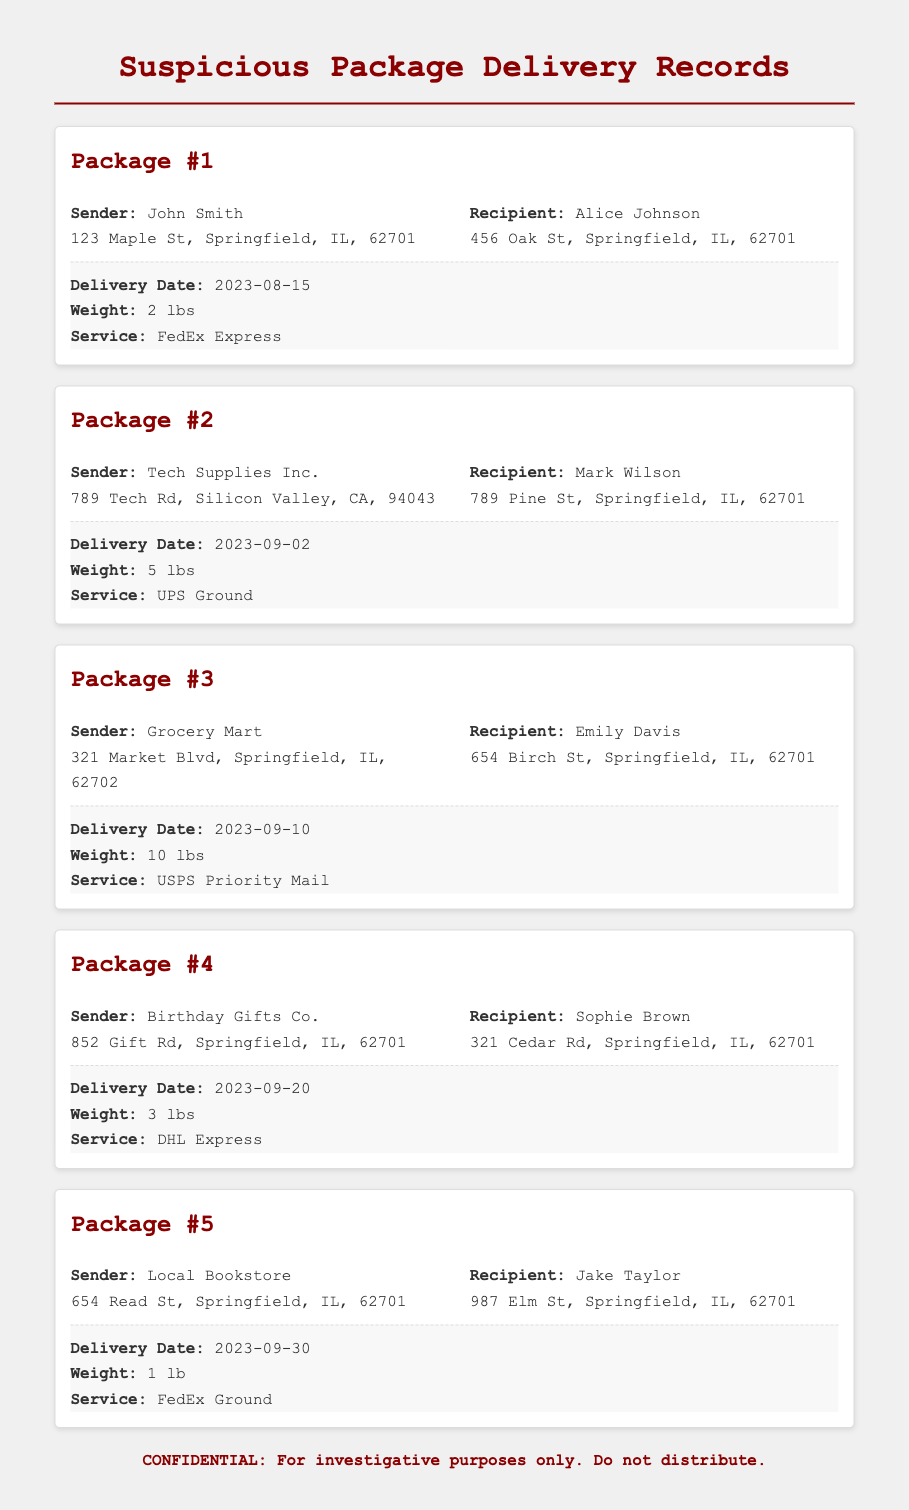What is the sender's name for Package #1? The sender's name for Package #1 is mentioned in the details section of the document.
Answer: John Smith What is the delivery date of Package #3? The delivery date of Package #3 is specifically listed in the package information.
Answer: 2023-09-10 Who is the recipient of Package #4? The recipient's name is provided in the details section for Package #4.
Answer: Sophie Brown What is the weight of Package #2? The weight of Package #2 is specified in the package information.
Answer: 5 lbs Which service was used for Package #5? The service used for Package #5 is stated in the package information section.
Answer: FedEx Ground How many packages were delivered on or after September 1st? To determine the number of packages delivered after a certain date, you need to refer to the delivery dates listed.
Answer: 4 Who sent the package weighing 10 lbs? The sender of the package can be identified from the details provided for the specified weight.
Answer: Grocery Mart What is the address of the recipient of Package #1? The recipient's address is included in the details section of Package #1.
Answer: 456 Oak St, Springfield, IL, 62701 